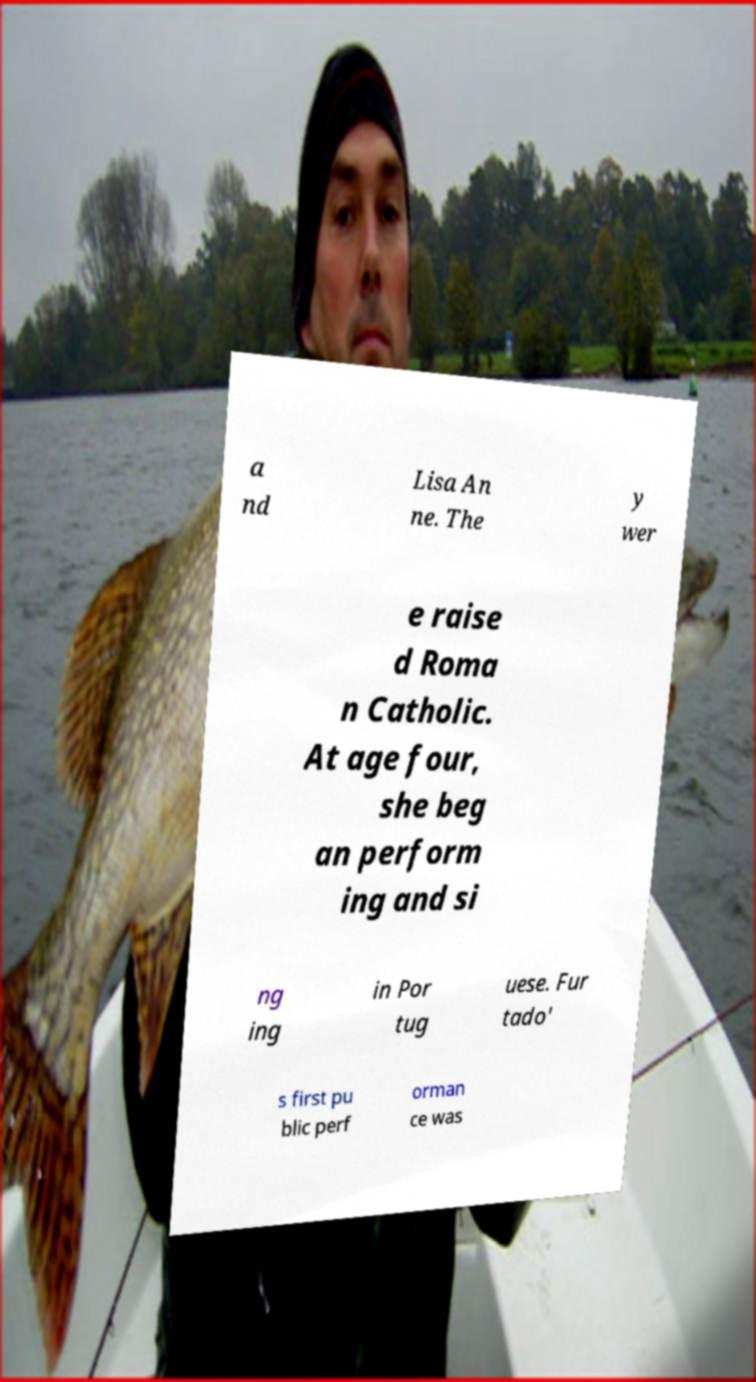Please read and relay the text visible in this image. What does it say? a nd Lisa An ne. The y wer e raise d Roma n Catholic. At age four, she beg an perform ing and si ng ing in Por tug uese. Fur tado' s first pu blic perf orman ce was 